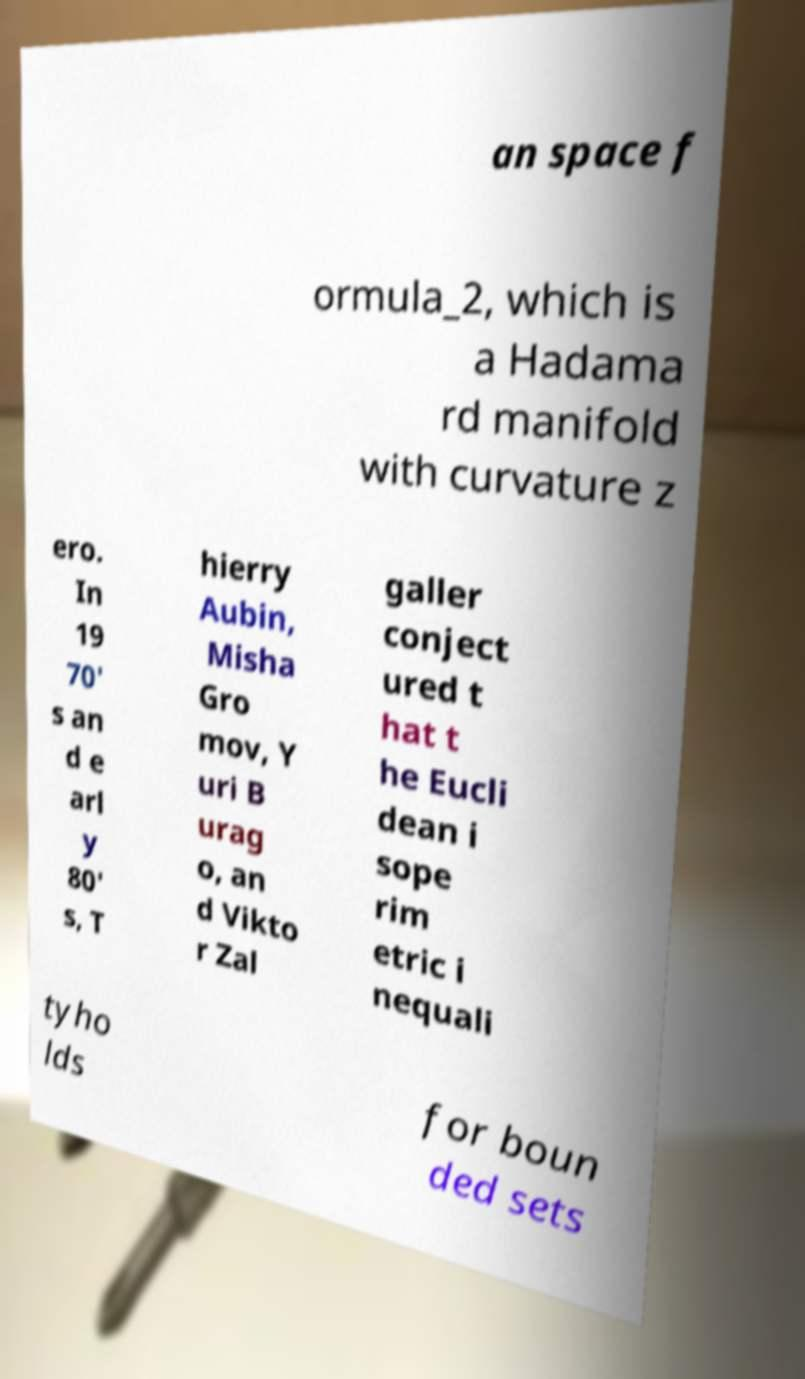What messages or text are displayed in this image? I need them in a readable, typed format. an space f ormula_2, which is a Hadama rd manifold with curvature z ero. In 19 70' s an d e arl y 80' s, T hierry Aubin, Misha Gro mov, Y uri B urag o, an d Vikto r Zal galler conject ured t hat t he Eucli dean i sope rim etric i nequali tyho lds for boun ded sets 